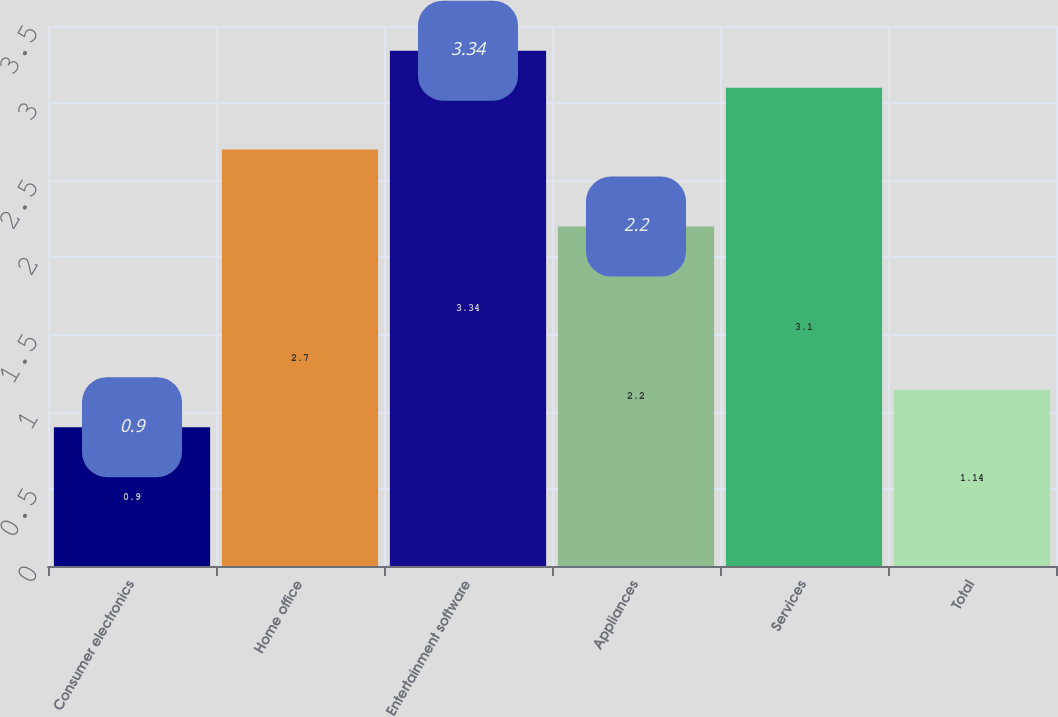Convert chart. <chart><loc_0><loc_0><loc_500><loc_500><bar_chart><fcel>Consumer electronics<fcel>Home office<fcel>Entertainment software<fcel>Appliances<fcel>Services<fcel>Total<nl><fcel>0.9<fcel>2.7<fcel>3.34<fcel>2.2<fcel>3.1<fcel>1.14<nl></chart> 